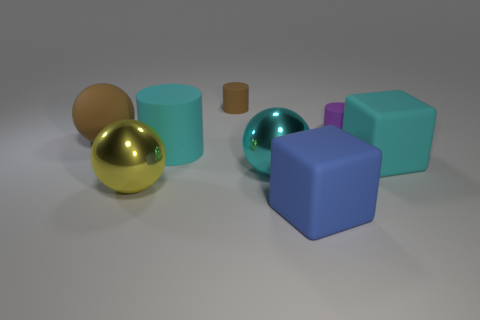Subtract all tiny cylinders. How many cylinders are left? 1 Subtract all balls. How many objects are left? 5 Add 2 brown rubber cylinders. How many objects exist? 10 Subtract all cyan cylinders. How many cylinders are left? 2 Subtract 0 red spheres. How many objects are left? 8 Subtract all gray cylinders. Subtract all cyan blocks. How many cylinders are left? 3 Subtract all blue cylinders. How many blue blocks are left? 1 Subtract all spheres. Subtract all brown metal cylinders. How many objects are left? 5 Add 3 big metallic balls. How many big metallic balls are left? 5 Add 6 cyan blocks. How many cyan blocks exist? 7 